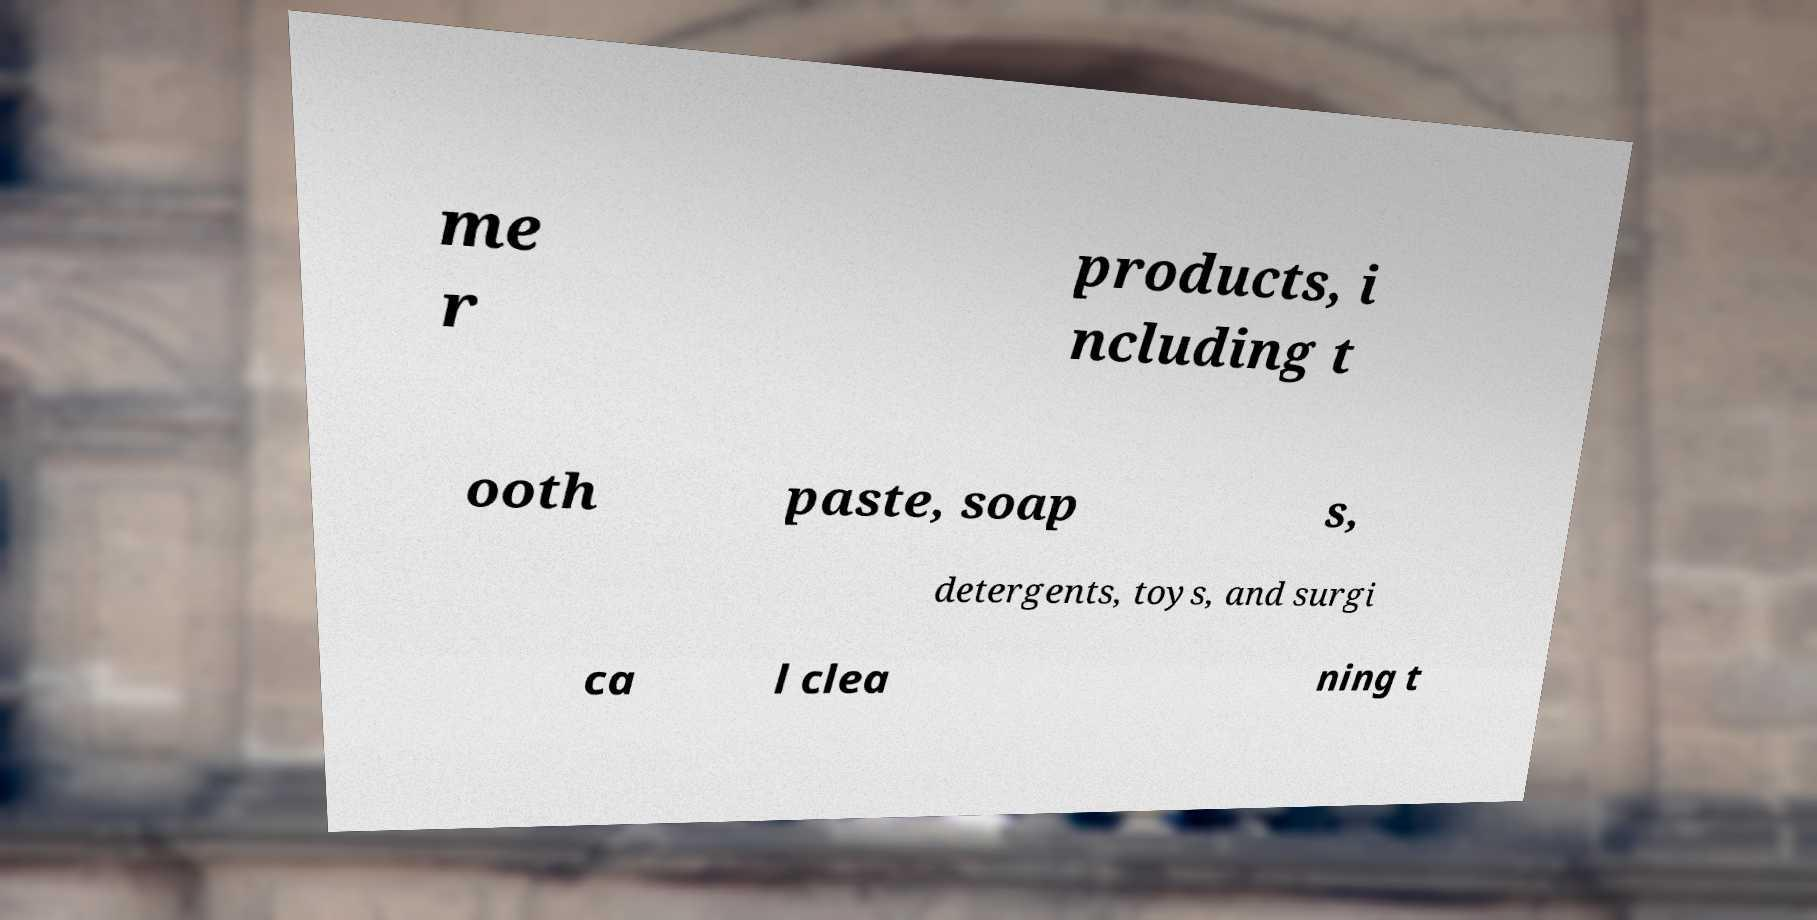What messages or text are displayed in this image? I need them in a readable, typed format. me r products, i ncluding t ooth paste, soap s, detergents, toys, and surgi ca l clea ning t 